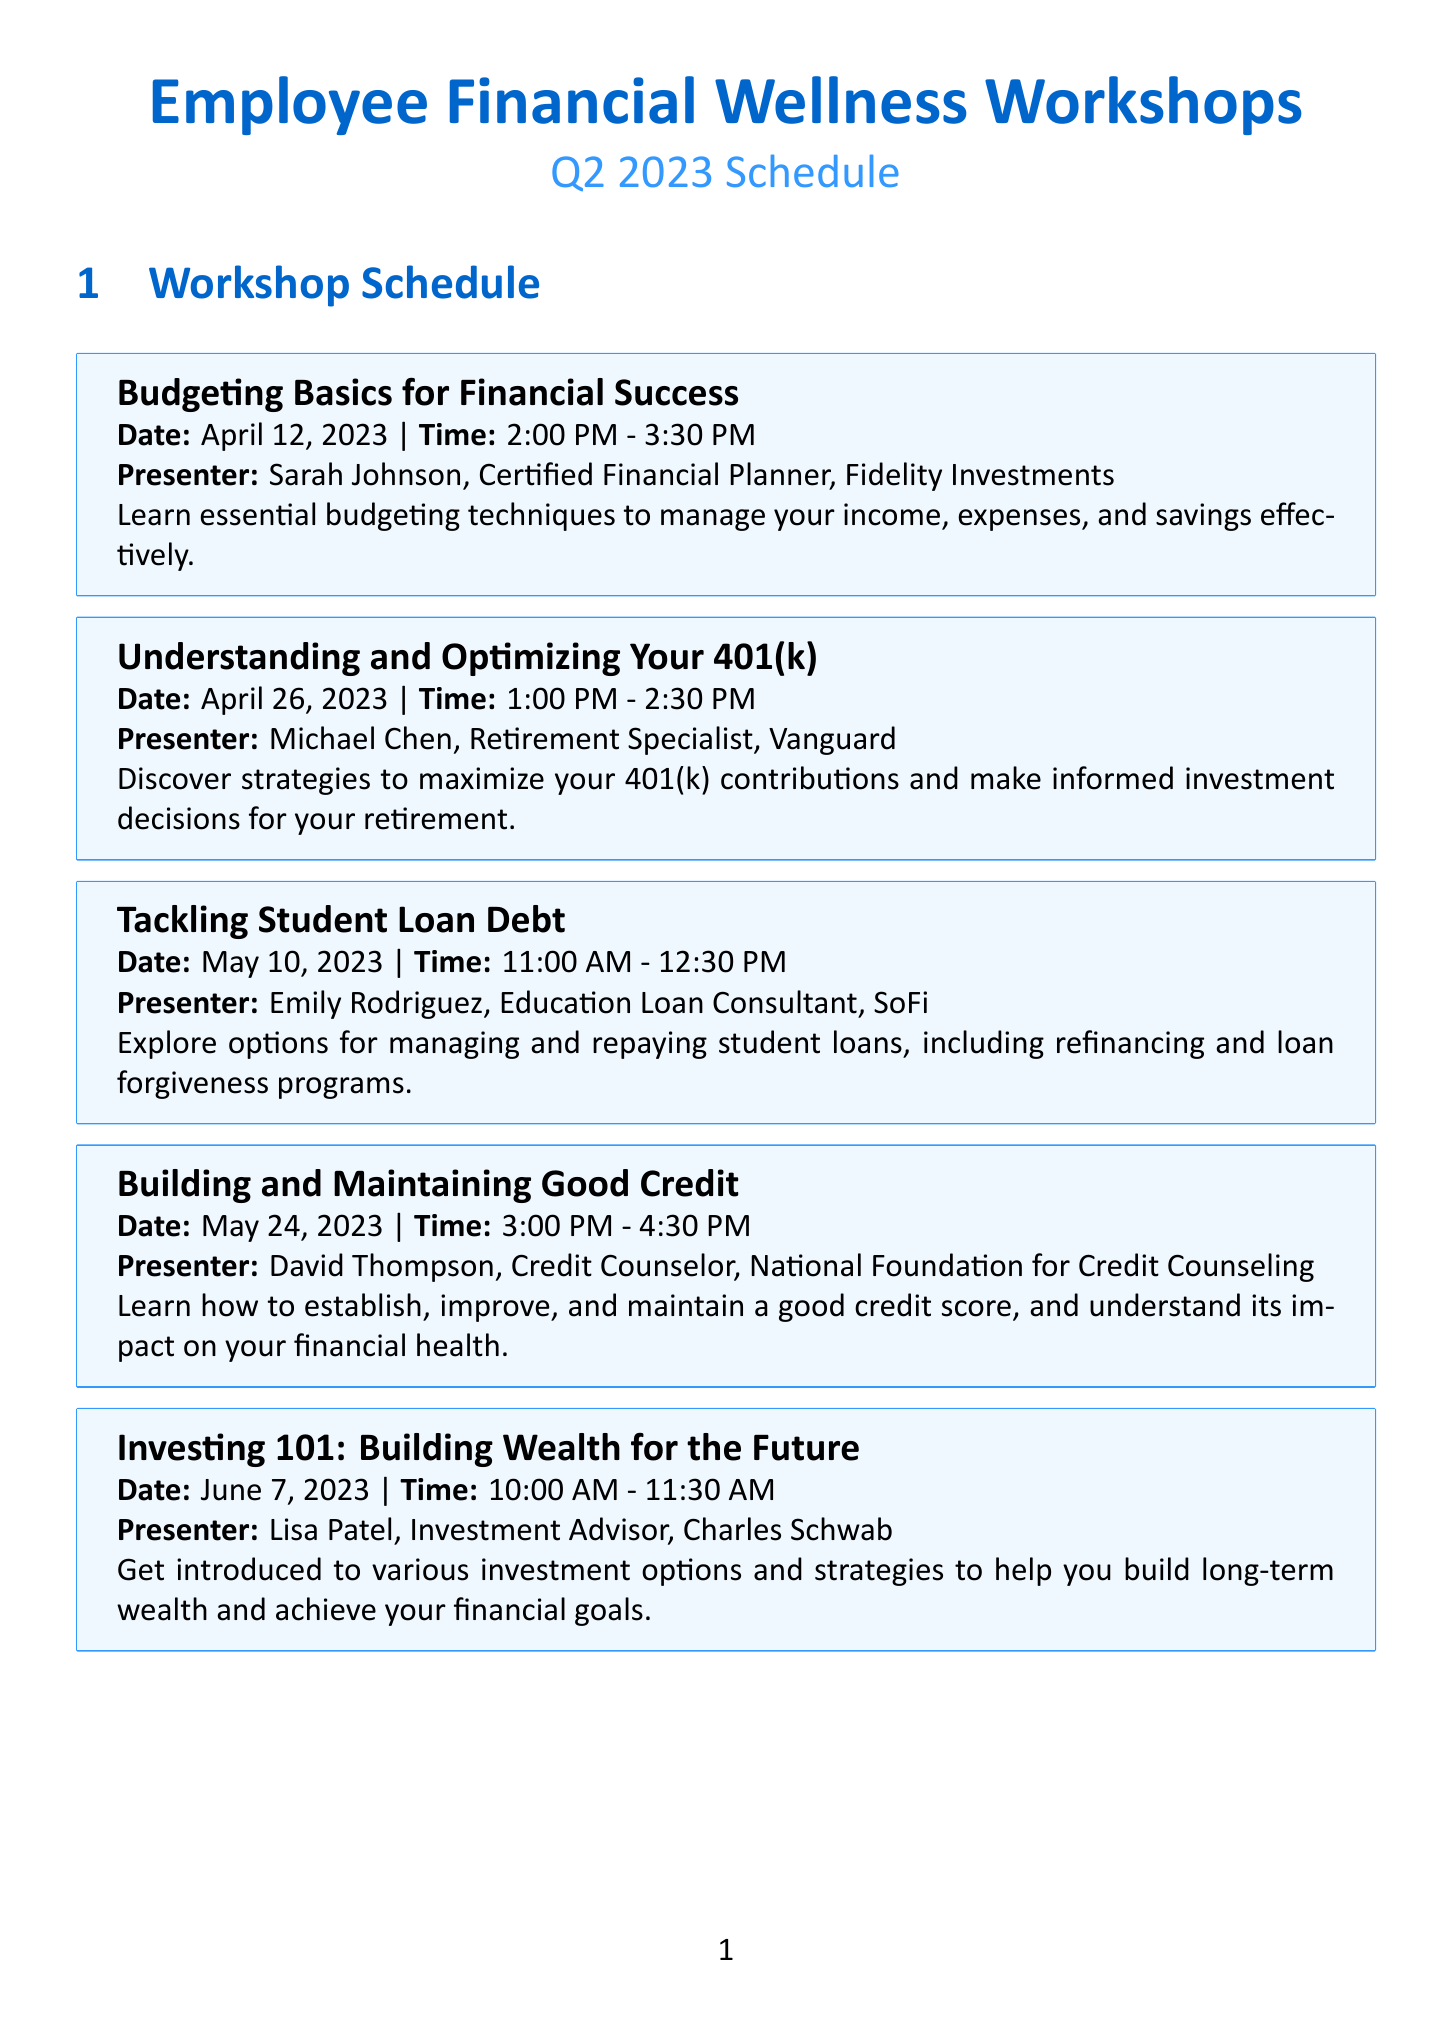What is the title of the first workshop? The title of the first workshop is the first item listed under the workshop schedule.
Answer: Budgeting Basics for Financial Success What is the date of the workshop on building credit? The date is specified next to the title of the respective workshop.
Answer: May 24, 2023 Who is presenting the workshop on student loan debt? The presenter's name is listed after the workshop title and date.
Answer: Emily Rodriguez What time is the Investing 101 workshop scheduled for? The time is provided alongside the date for each workshop.
Answer: 10:00 AM - 11:30 AM How many workshops are listed in total? The total number of workshops can be counted from the list in the document.
Answer: 6 Which presenter specializes in healthcare costs? The presentation details include the name of the presenter for each topic.
Answer: Robert Wilson What type of additional resource provides confidential support for financial stress? The resource type can be located by looking at the list of additional resources in the document.
Answer: Employee Assistance Program (EAP) What is the contact email for financial coaching sessions? The contact email is provided in the description of the corresponding resource.
Answer: financialwellness@companyname.com When is the workshop on optimizing a 401(k) taking place? The date is given alongside the title of the workshop in the schedule.
Answer: April 26, 2023 